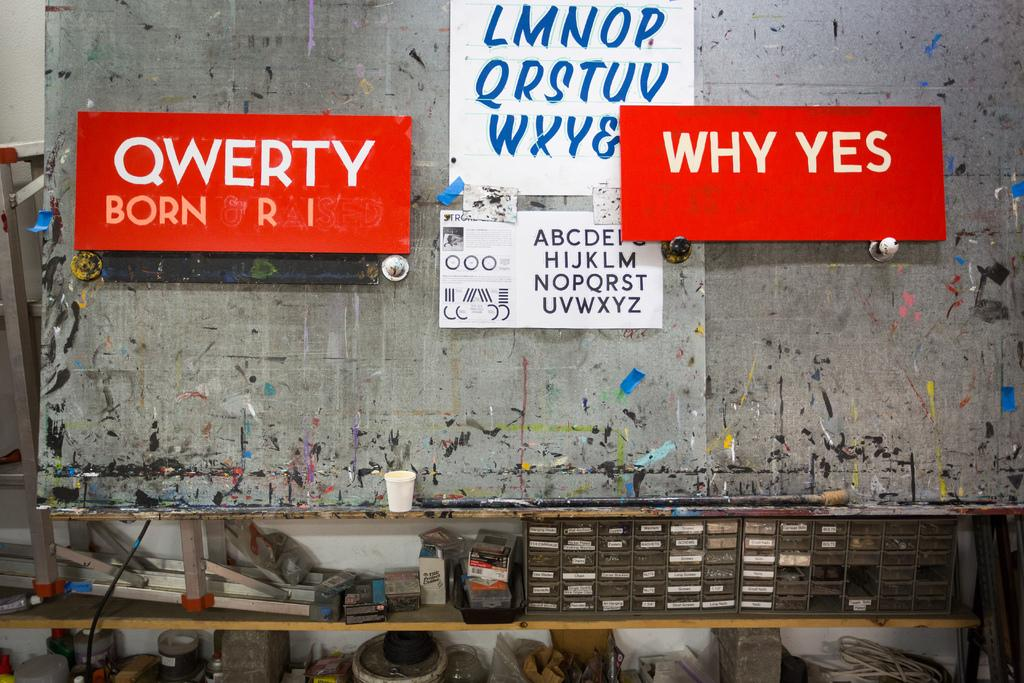<image>
Share a concise interpretation of the image provided. a few signs one of which says qwerty on it 